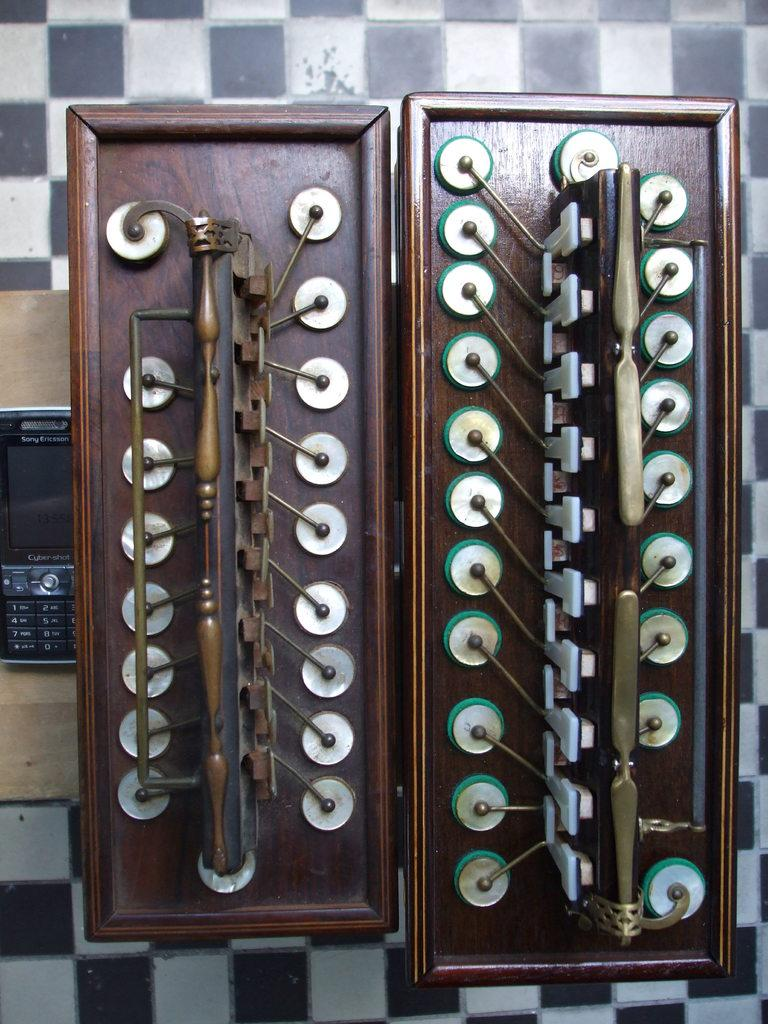What object is located on the left side of the image? There is a mobile in the image, and it is on the left side. What is the mobile placed on? The mobile is placed on a wooden surface. What can be seen on the right side of the image? There appears to be a musical instrument on the right side of the image. How many pins are attached to the badge in the image? There is no badge or pin present in the image. What type of club is visible in the image? There is no club present in the image. 